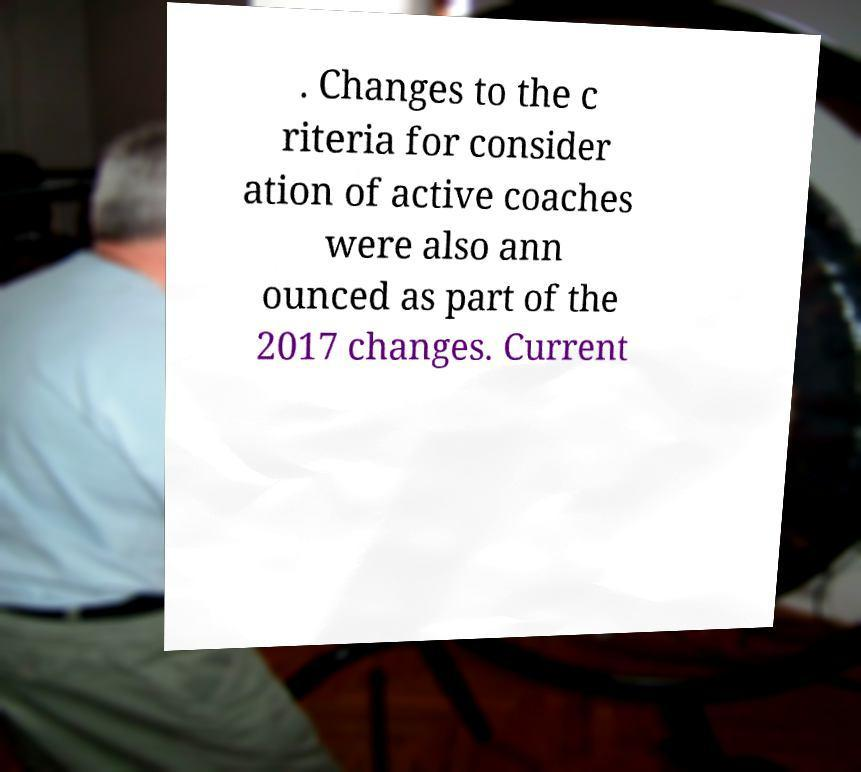Please identify and transcribe the text found in this image. . Changes to the c riteria for consider ation of active coaches were also ann ounced as part of the 2017 changes. Current 